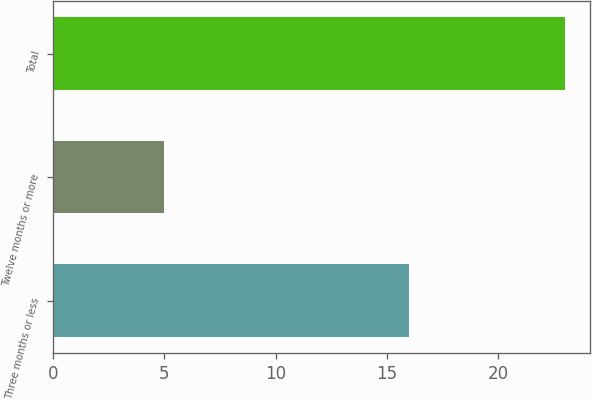<chart> <loc_0><loc_0><loc_500><loc_500><bar_chart><fcel>Three months or less<fcel>Twelve months or more<fcel>Total<nl><fcel>16<fcel>5<fcel>23<nl></chart> 